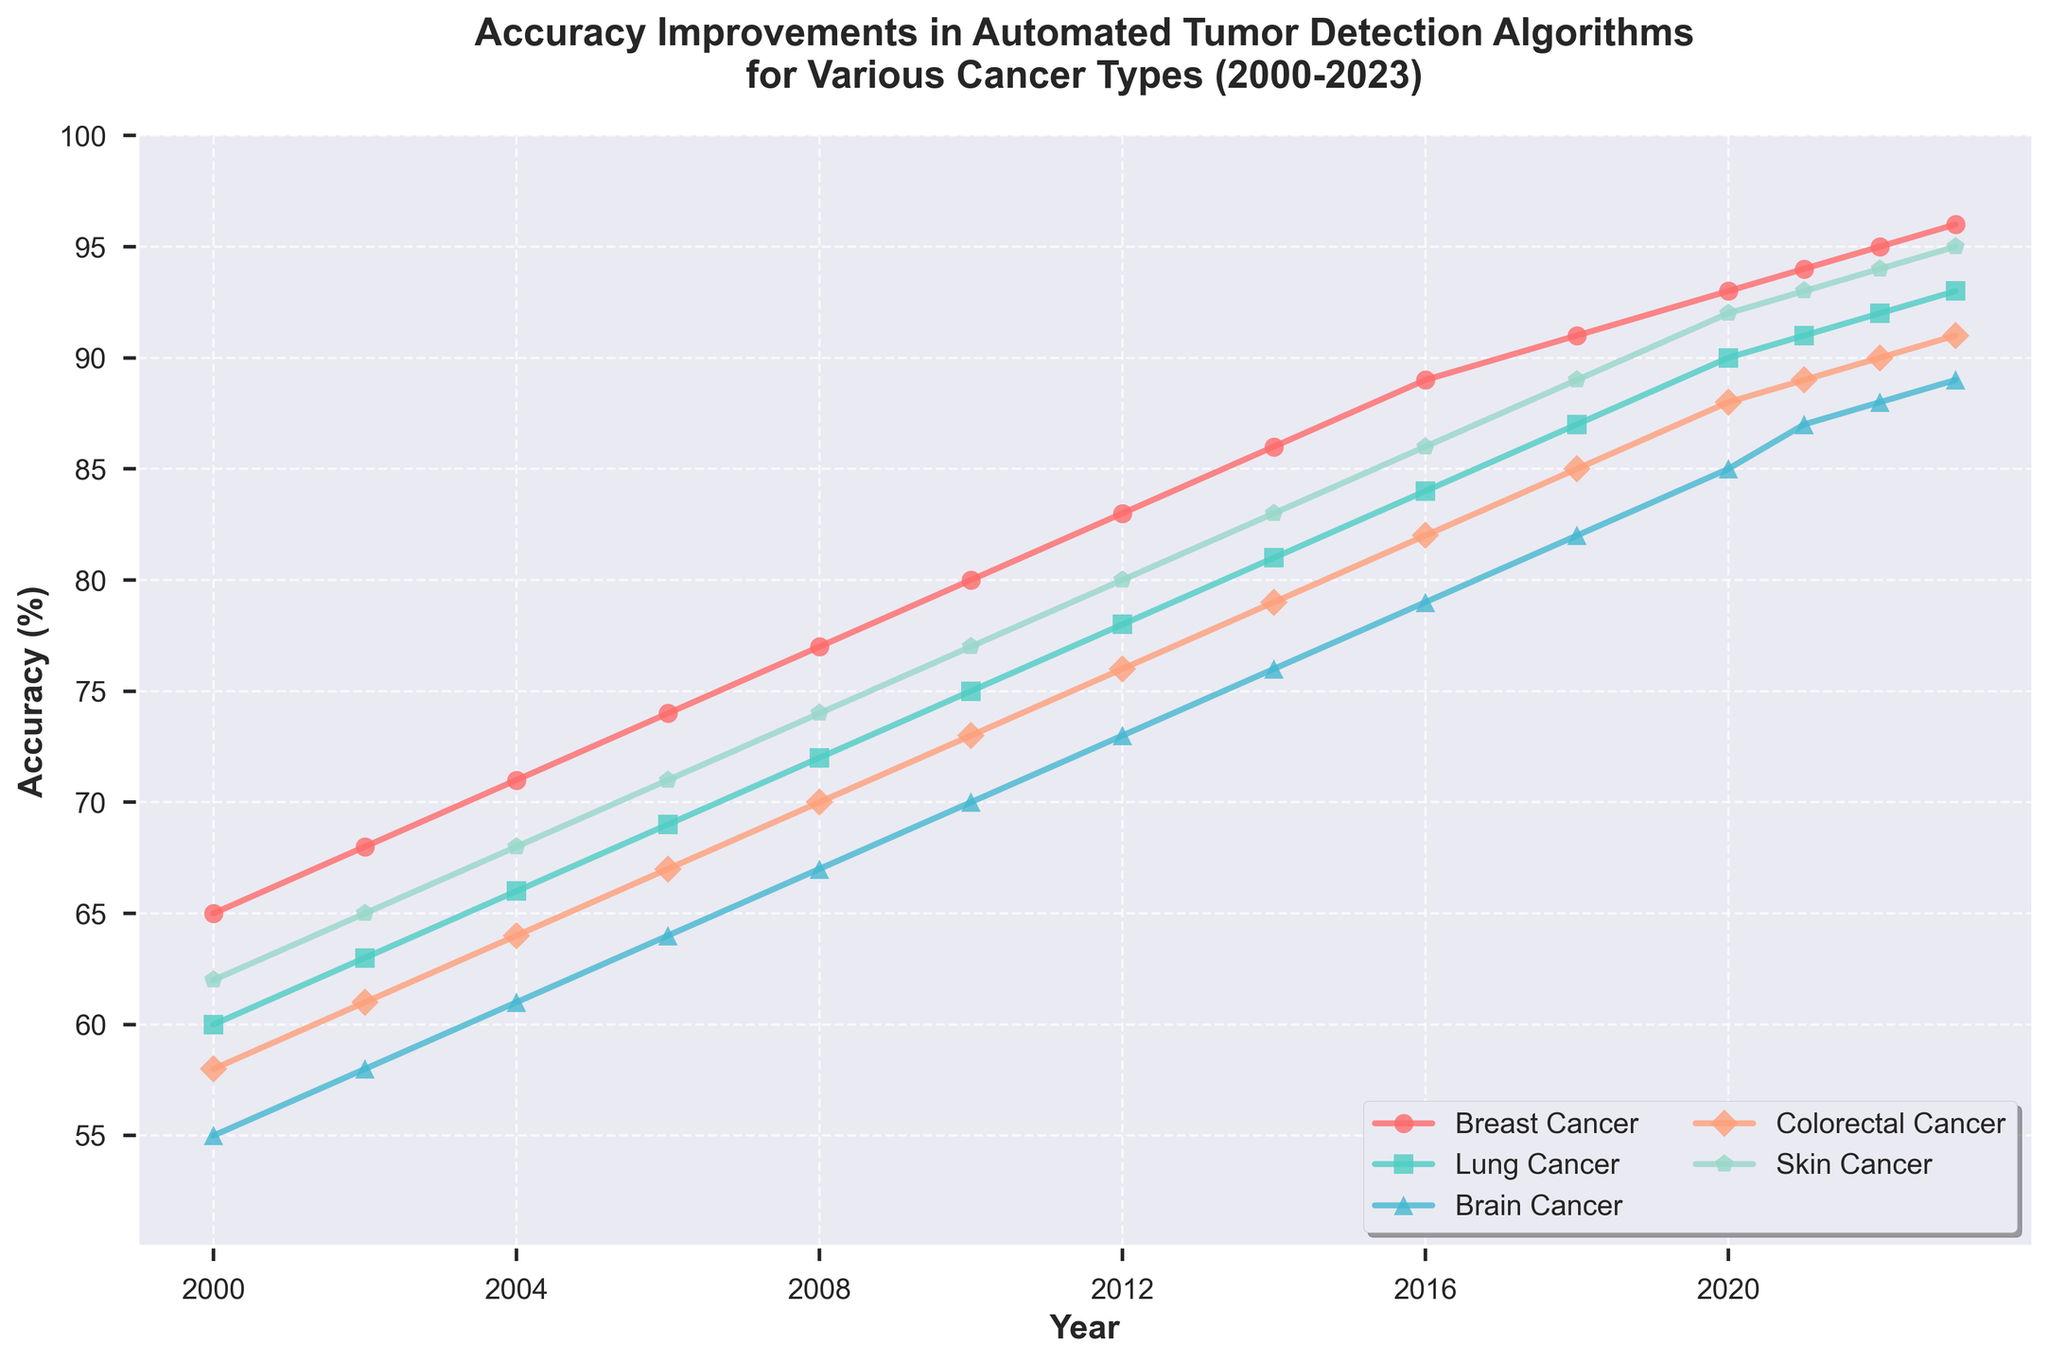What is the overall trend in accuracy for automated tumor detection in breast cancer from 2000 to 2023? The chart shows the accuracy in detecting breast cancer steadily increasing from 65% in 2000 to 96% in 2023. This consistent upward movement indicates significant improvements in automated tumor detection algorithms over this period.
Answer: Upward trend Which cancer type had the lowest accuracy in 2006? By observing the data points for 2006, it is clear that Brain cancer had the lowest accuracy at 64%, compared to Breast cancer, Lung cancer, Colorectal cancer, and Skin cancer, which had higher accuracies.
Answer: Brain cancer Between 2000 and 2010, which cancer type experienced the greatest increase in detection accuracy? To find the greatest increase, calculate the difference between the 2010 and 2000 accuracy values for each cancer type: Breast Cancer (80-65=15), Lung Cancer (75-60=15), Brain Cancer (70-55=15), Colorectal Cancer (73-58=15), and Skin Cancer (77-62=15). All cancer types experienced an equal increase of 15%.
Answer: All equal How does the accuracy of Skin Cancer in 2023 compare to the accuracy of Lung Cancer in 2014? In 2023, the accuracy of Skin Cancer is 95%, whereas in 2014, the accuracy of Lung Cancer is 81%. Comparing these values, Skin Cancer in 2023 has higher accuracy.
Answer: Skin Cancer is higher What is the average detection accuracy for Brain Cancer in the years 2010, 2012, and 2014? To find the average accuracy: (2010: 70% + 2012: 73% + 2014: 76%) / 3 = 219 / 3 = 73%. Therefore, the average accuracy is 73%.
Answer: 73% Compare the rate of accuracy improvement between Breast Cancer and Brain Cancer from 2000 to 2023. The rate of accuracy improvement for Breast Cancer is (96% - 65%) = 31%. For Brain Cancer, it is (89% - 55%) = 34%. Brain Cancer has a slightly higher rate of improvement over this period.
Answer: Brain Cancer is higher Which year had the highest overall accuracy for automated tumor detection across all cancer types? By examining each year's data, 2023 shows the highest accuracy values for all cancer types, notably reaching as high as 96% for Breast Cancer and 95% for Skin Cancer.
Answer: 2023 What are the two cancer types with the closest detection accuracy values in 2022? In 2022, Lung Cancer and Brain Cancer have the closest detection accuracy values of 92% and 88%, respectively. The difference of 4% is the smallest among all pairs of cancer types.
Answer: Lung Cancer and Brain Cancer Is there any cancer type whose accuracy rate never reached 90% by 2023? The chart shows that Brain Cancer is the only type that did not reach a 90% accuracy rate by 2023, with a final accuracy of 89%.
Answer: Brain Cancer 